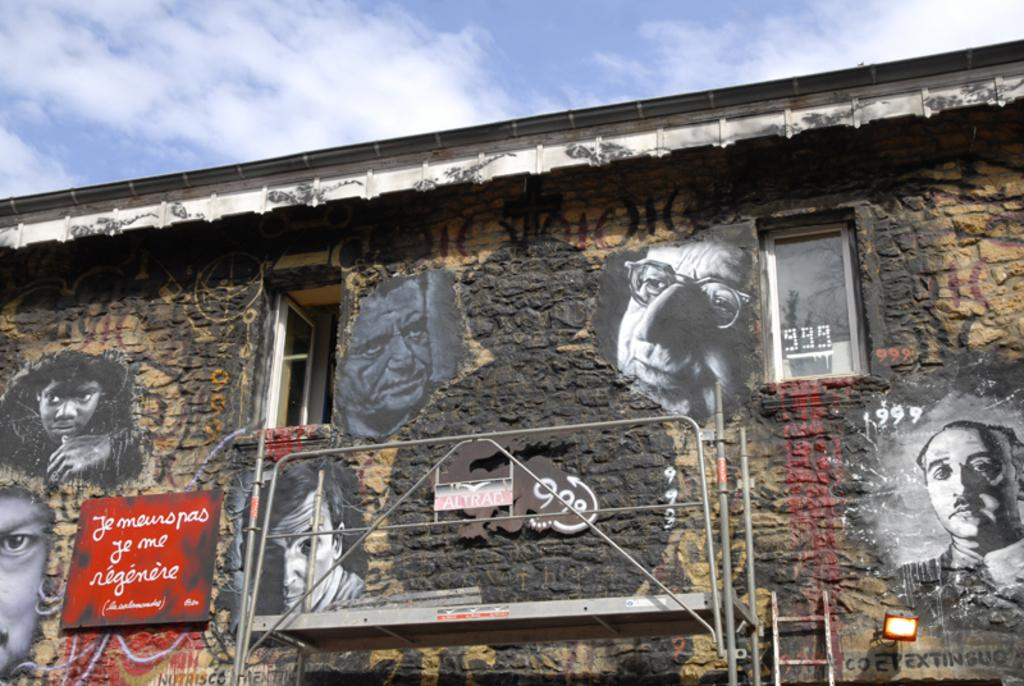What can be seen on the wall in the image? There are pictures of persons on a wall in the image. What architectural features are present in the image? There are windows and a ladder in the image. What type of light source is visible in the image? There is a light in the image. What material is the ladder made of? The ladder is made of metal, as mentioned in the facts. What can be seen in the sky in the background of the image? There are clouds in the sky in the background of the image. What color is the crayon used to draw the pictures on the wall? There is no crayon mentioned in the image, and the color of the pictures is not specified. Can you tell me how many teeth are visible in the image? There are no teeth visible in the image. 